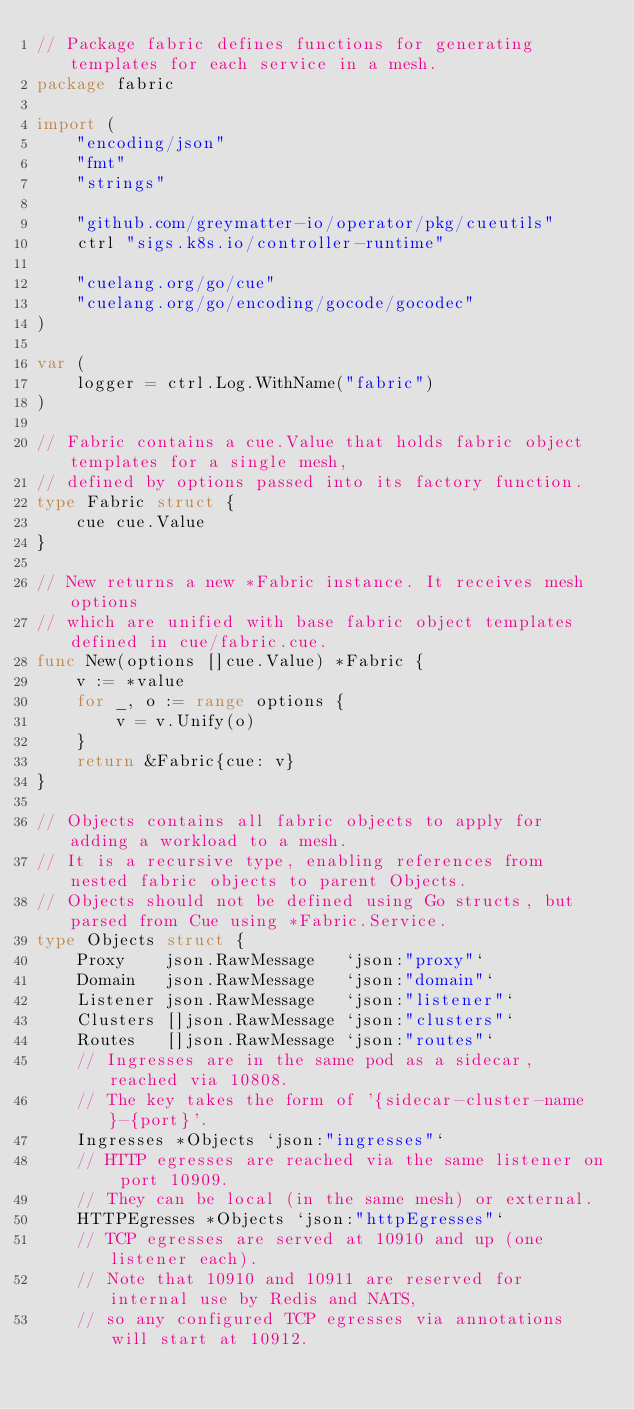<code> <loc_0><loc_0><loc_500><loc_500><_Go_>// Package fabric defines functions for generating templates for each service in a mesh.
package fabric

import (
	"encoding/json"
	"fmt"
	"strings"

	"github.com/greymatter-io/operator/pkg/cueutils"
	ctrl "sigs.k8s.io/controller-runtime"

	"cuelang.org/go/cue"
	"cuelang.org/go/encoding/gocode/gocodec"
)

var (
	logger = ctrl.Log.WithName("fabric")
)

// Fabric contains a cue.Value that holds fabric object templates for a single mesh,
// defined by options passed into its factory function.
type Fabric struct {
	cue cue.Value
}

// New returns a new *Fabric instance. It receives mesh options
// which are unified with base fabric object templates defined in cue/fabric.cue.
func New(options []cue.Value) *Fabric {
	v := *value
	for _, o := range options {
		v = v.Unify(o)
	}
	return &Fabric{cue: v}
}

// Objects contains all fabric objects to apply for adding a workload to a mesh.
// It is a recursive type, enabling references from nested fabric objects to parent Objects.
// Objects should not be defined using Go structs, but parsed from Cue using *Fabric.Service.
type Objects struct {
	Proxy    json.RawMessage   `json:"proxy"`
	Domain   json.RawMessage   `json:"domain"`
	Listener json.RawMessage   `json:"listener"`
	Clusters []json.RawMessage `json:"clusters"`
	Routes   []json.RawMessage `json:"routes"`
	// Ingresses are in the same pod as a sidecar, reached via 10808.
	// The key takes the form of '{sidecar-cluster-name}-{port}'.
	Ingresses *Objects `json:"ingresses"`
	// HTTP egresses are reached via the same listener on port 10909.
	// They can be local (in the same mesh) or external.
	HTTPEgresses *Objects `json:"httpEgresses"`
	// TCP egresses are served at 10910 and up (one listener each).
	// Note that 10910 and 10911 are reserved for internal use by Redis and NATS,
	// so any configured TCP egresses via annotations will start at 10912.</code> 